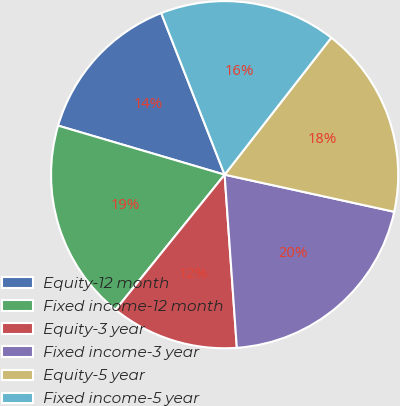Convert chart to OTSL. <chart><loc_0><loc_0><loc_500><loc_500><pie_chart><fcel>Equity-12 month<fcel>Fixed income-12 month<fcel>Equity-3 year<fcel>Fixed income-3 year<fcel>Equity-5 year<fcel>Fixed income-5 year<nl><fcel>14.49%<fcel>18.75%<fcel>11.93%<fcel>20.45%<fcel>17.9%<fcel>16.48%<nl></chart> 